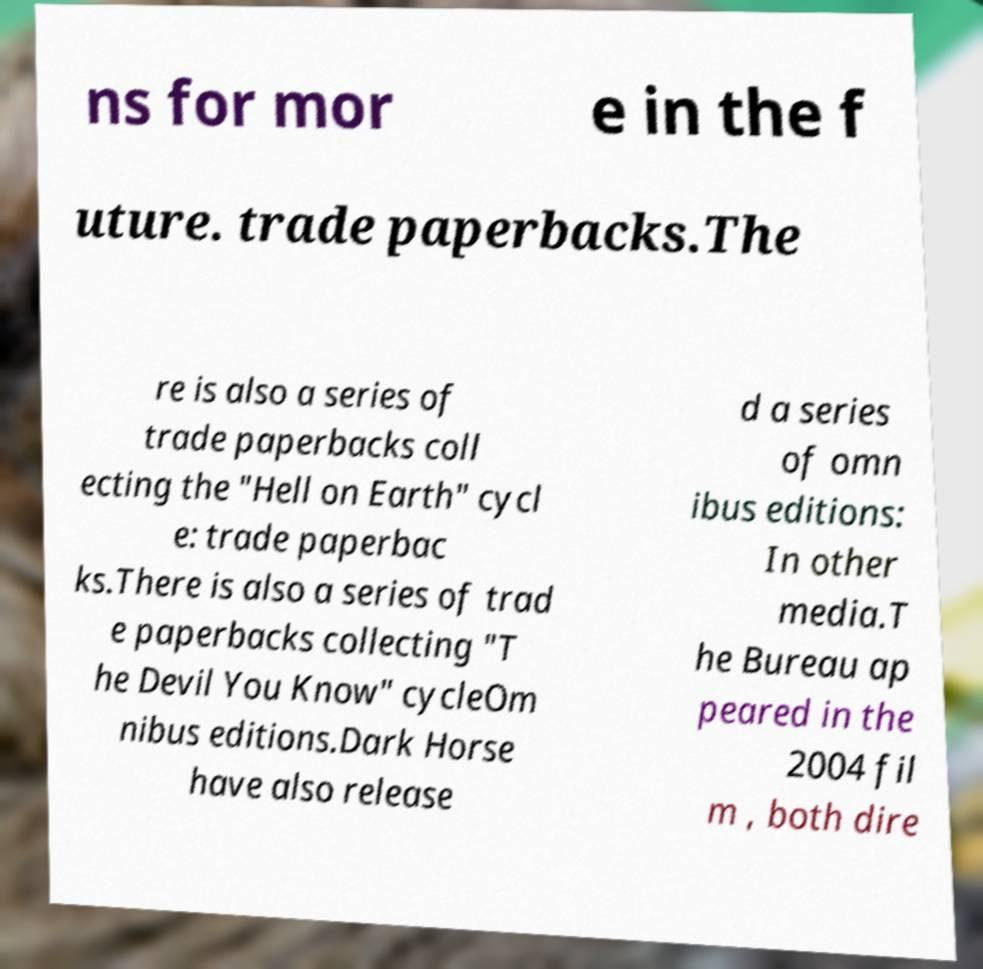What messages or text are displayed in this image? I need them in a readable, typed format. ns for mor e in the f uture. trade paperbacks.The re is also a series of trade paperbacks coll ecting the "Hell on Earth" cycl e: trade paperbac ks.There is also a series of trad e paperbacks collecting "T he Devil You Know" cycleOm nibus editions.Dark Horse have also release d a series of omn ibus editions: In other media.T he Bureau ap peared in the 2004 fil m , both dire 